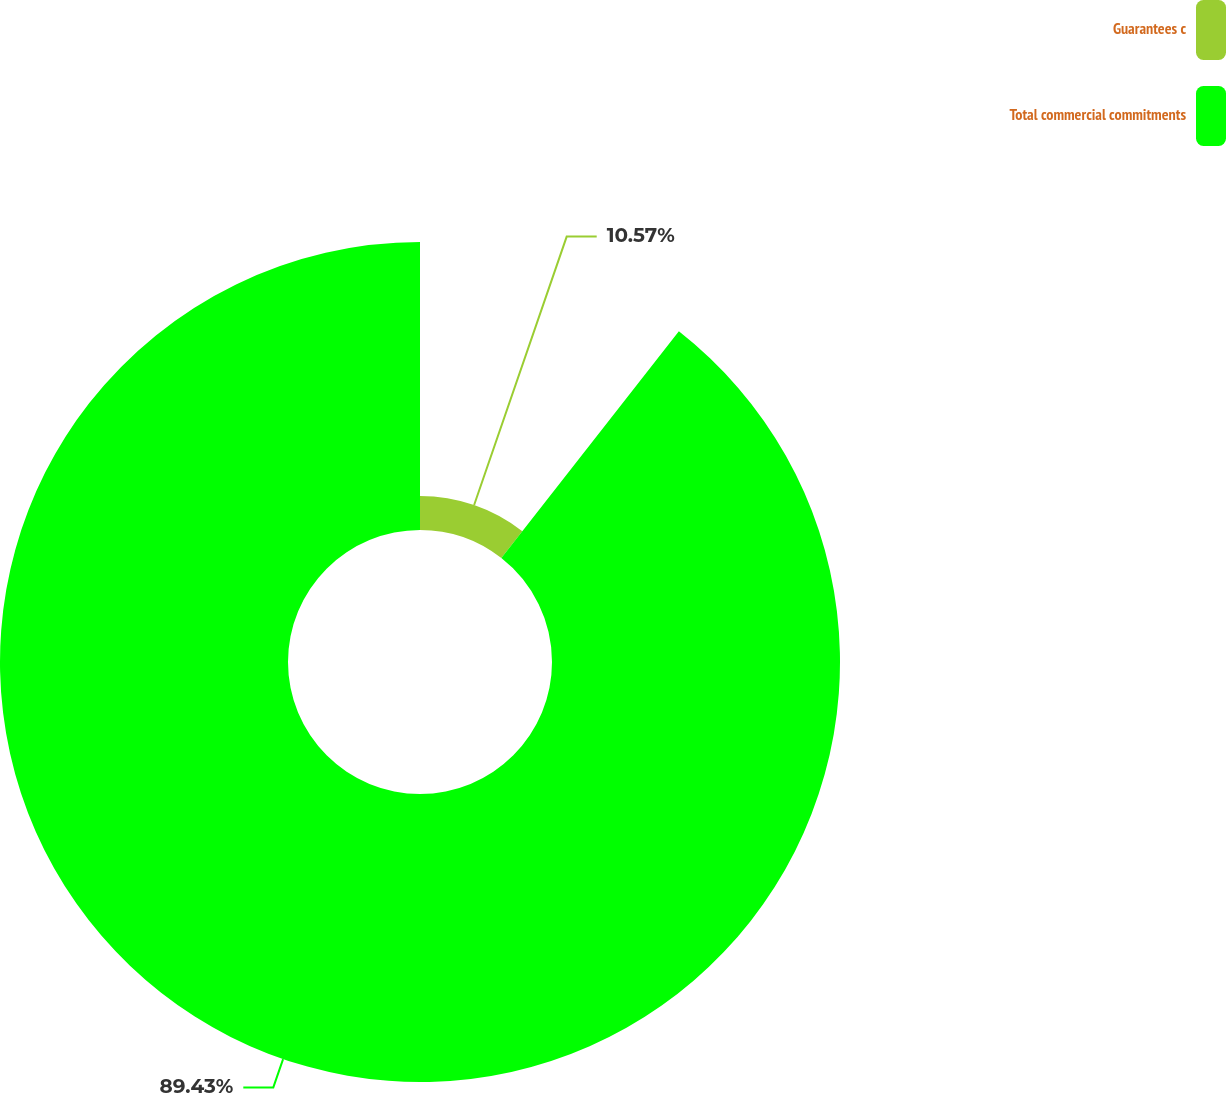Convert chart. <chart><loc_0><loc_0><loc_500><loc_500><pie_chart><fcel>Guarantees c<fcel>Total commercial commitments<nl><fcel>10.57%<fcel>89.43%<nl></chart> 